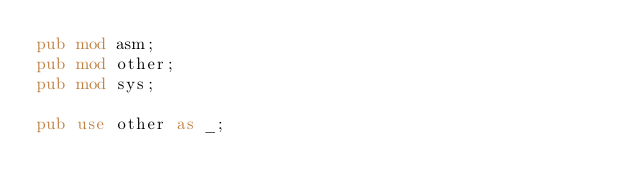Convert code to text. <code><loc_0><loc_0><loc_500><loc_500><_Rust_>pub mod asm;
pub mod other;
pub mod sys;

pub use other as _;
</code> 